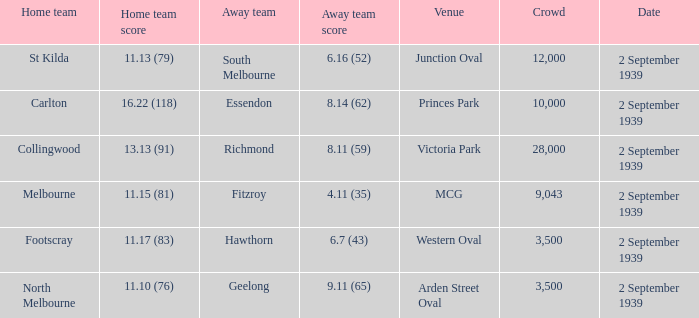What was the crowd size of the match featuring Hawthorn as the Away team? 3500.0. 